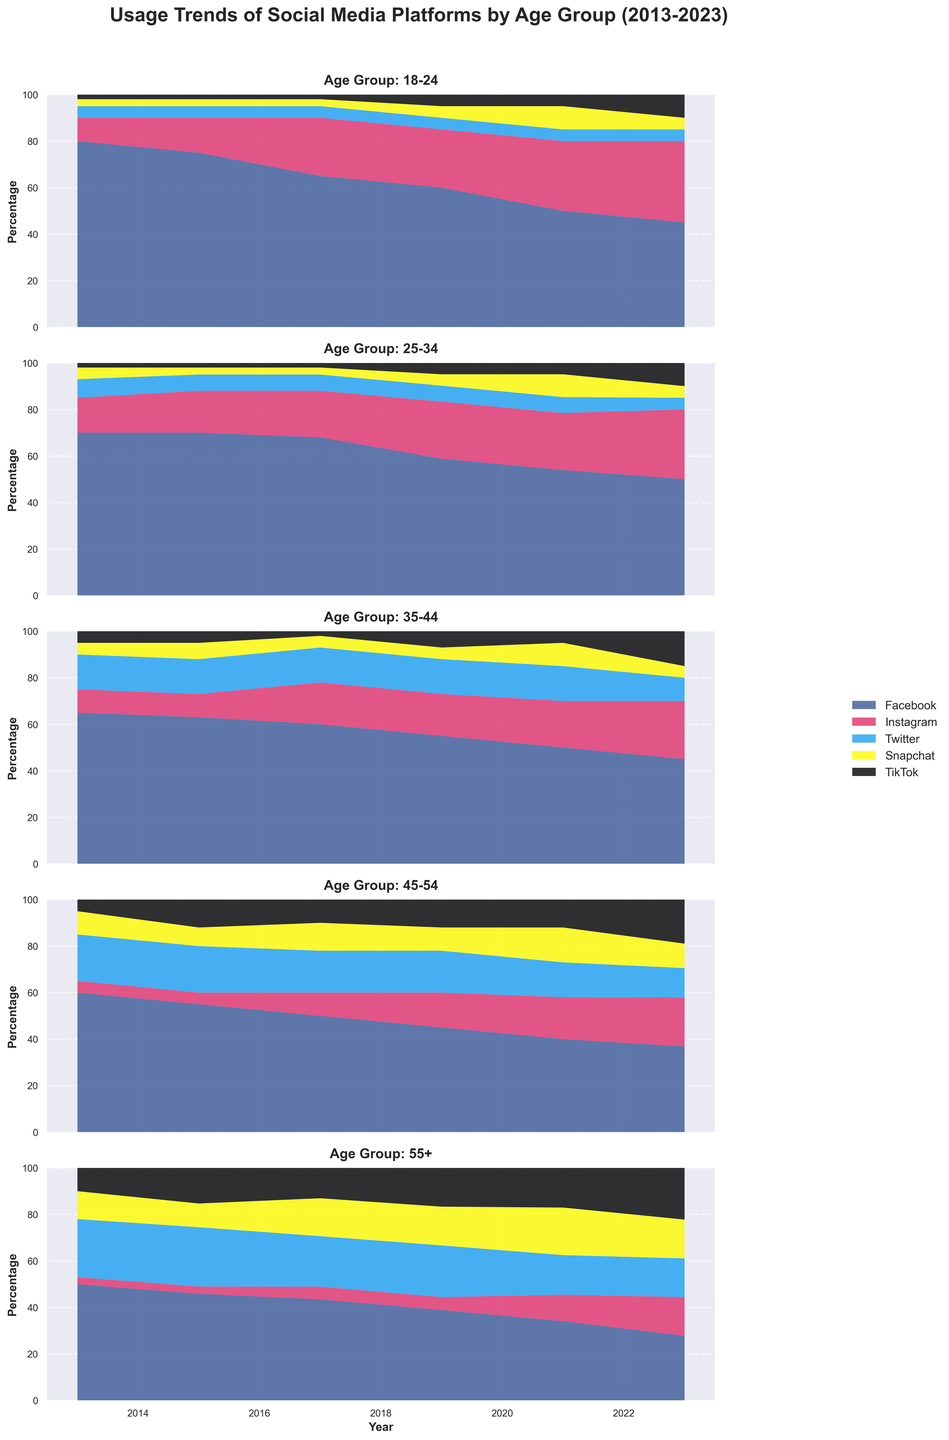What is the title of the figure? The title is generally placed at the top of the figure and is often written in large, bold text to catch attention. The title of the figure is "Usage Trends of Social Media Platforms by Age Group (2013-2023)" as described in the figure description.
Answer: "Usage Trends of Social Media Platforms by Age Group (2013-2023)" Which social media platform has seen the largest increase in usage among the 18-24 age group from 2013 to 2023? For the 18-24 age group, compare the values of each platform in 2013 and 2023. Facebook decreased from 80% to 45%, Instagram increased from 10% to 35%, Twitter remained at 5%, Snapchat remained at 5%, and TikTok increased from 2% to 10%. Instagram had the largest increase.
Answer: Instagram How did the usage of Facebook change among the age group 55+ from 2013 to 2023? For the 55+ age group, the usage of Facebook is 50% in 2013 and decreases to 25% in 2023. This represents a decrease of 25 percentage points over the 10-year period.
Answer: Decreased Which age group showed no change in Twitter usage from 2019 to 2023? To determine this, we need to look at the Twitter percentages for each age group in 2019 and 2023. We can see that both the 18-24 and 25-34 age groups had the same 5% usage in both 2019 and 2023.
Answer: 18-24, 25-34 In which age group did TikTok see the most significant growth from 2019 to 2023? To identify the most significant growth, the absolute difference in TikTok percentages between 2019 and 2023 for each age group must be computed. Comparing these, the 35-44 age group saw an increase from 7% to 15%, a difference of 8 percentage points, which is larger than any other group's change in TikTok usage.
Answer: 35-44 Which social media platform had the highest usage among the 25-34 age group in 2015? Inspect the values of each platform for the 25-34 age group in 2015. Facebook had a usage of 70%, which is higher than any other platform for that year and age group.
Answer: Facebook What trend can be observed for Snapchat usage across all age groups from 2013 to 2023? Analyze the trend across all age groups and years for Snapchat. In general, the usage of Snapchat does not present significant increases or decreases, remaining relatively stable for all age groups over this period.
Answer: Relatively stable Between 2015 and 2017, which age group experienced the greatest increase in Instagram usage and by how much? Compare the Instagram percentages for each age group between 2015 and 2017: 18-24 (15% to 25%), 25-34 (18% to 20%), 35-44 (10% to 18%), 45-54 (5% to 10%), and 55+ (3% to 5%). The age group 35-44 saw the greatest increase of 8 percentage points.
Answer: 35-44, 8 percentage points By 2021, which age group has the highest percentage of TikTok users? Examine the 2021 data for TikTok use across all age groups. For 2021, the 55+ age group has the highest TikTok use at 15%.
Answer: 55+ How does the social media usage trend differ between the youngest and oldest age groups over the given years? Compare trends in the 18-24 and 55+ age groups from 2013 to 2023. For the 18-24 group, Facebook usage generally decreases, while Instagram and TikTok usage increase. In contrast, the 55+ group shows a decline in Facebook usage and a steady rise in TikTok and Snapchat usage.
Answer: Younger: Facebook decreases, Instagram & TikTok increase; Older: Facebook decreases, TikTok & Snapchat increase 